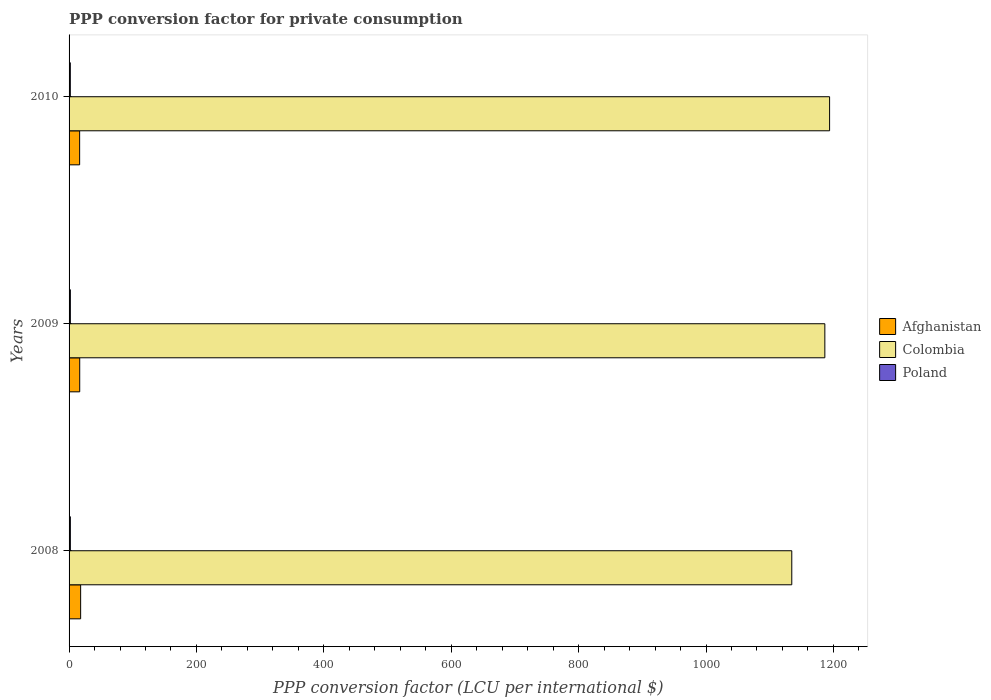How many different coloured bars are there?
Offer a very short reply. 3. Are the number of bars on each tick of the Y-axis equal?
Your response must be concise. Yes. How many bars are there on the 1st tick from the top?
Ensure brevity in your answer.  3. What is the label of the 3rd group of bars from the top?
Your answer should be compact. 2008. What is the PPP conversion factor for private consumption in Afghanistan in 2010?
Offer a terse response. 16.59. Across all years, what is the maximum PPP conversion factor for private consumption in Poland?
Your response must be concise. 2.02. Across all years, what is the minimum PPP conversion factor for private consumption in Poland?
Your answer should be very brief. 1.96. In which year was the PPP conversion factor for private consumption in Colombia maximum?
Provide a short and direct response. 2010. What is the total PPP conversion factor for private consumption in Poland in the graph?
Your response must be concise. 6. What is the difference between the PPP conversion factor for private consumption in Afghanistan in 2009 and that in 2010?
Offer a very short reply. 0.12. What is the difference between the PPP conversion factor for private consumption in Poland in 2010 and the PPP conversion factor for private consumption in Afghanistan in 2008?
Provide a succinct answer. -16.19. What is the average PPP conversion factor for private consumption in Poland per year?
Keep it short and to the point. 2. In the year 2010, what is the difference between the PPP conversion factor for private consumption in Colombia and PPP conversion factor for private consumption in Afghanistan?
Ensure brevity in your answer.  1177.42. In how many years, is the PPP conversion factor for private consumption in Poland greater than 920 LCU?
Offer a terse response. 0. What is the ratio of the PPP conversion factor for private consumption in Poland in 2008 to that in 2009?
Your response must be concise. 1. Is the PPP conversion factor for private consumption in Poland in 2008 less than that in 2009?
Offer a very short reply. No. Is the difference between the PPP conversion factor for private consumption in Colombia in 2009 and 2010 greater than the difference between the PPP conversion factor for private consumption in Afghanistan in 2009 and 2010?
Provide a succinct answer. No. What is the difference between the highest and the second highest PPP conversion factor for private consumption in Colombia?
Your response must be concise. 7.45. What is the difference between the highest and the lowest PPP conversion factor for private consumption in Afghanistan?
Your response must be concise. 1.57. In how many years, is the PPP conversion factor for private consumption in Afghanistan greater than the average PPP conversion factor for private consumption in Afghanistan taken over all years?
Give a very brief answer. 1. Is it the case that in every year, the sum of the PPP conversion factor for private consumption in Poland and PPP conversion factor for private consumption in Colombia is greater than the PPP conversion factor for private consumption in Afghanistan?
Provide a succinct answer. Yes. Are all the bars in the graph horizontal?
Ensure brevity in your answer.  Yes. Are the values on the major ticks of X-axis written in scientific E-notation?
Make the answer very short. No. Does the graph contain any zero values?
Offer a very short reply. No. Does the graph contain grids?
Make the answer very short. No. Where does the legend appear in the graph?
Your answer should be very brief. Center right. What is the title of the graph?
Your answer should be compact. PPP conversion factor for private consumption. What is the label or title of the X-axis?
Offer a very short reply. PPP conversion factor (LCU per international $). What is the PPP conversion factor (LCU per international $) in Afghanistan in 2008?
Provide a short and direct response. 18.15. What is the PPP conversion factor (LCU per international $) of Colombia in 2008?
Make the answer very short. 1134.65. What is the PPP conversion factor (LCU per international $) of Poland in 2008?
Offer a very short reply. 2.02. What is the PPP conversion factor (LCU per international $) of Afghanistan in 2009?
Keep it short and to the point. 16.71. What is the PPP conversion factor (LCU per international $) in Colombia in 2009?
Make the answer very short. 1186.56. What is the PPP conversion factor (LCU per international $) in Poland in 2009?
Ensure brevity in your answer.  2.02. What is the PPP conversion factor (LCU per international $) in Afghanistan in 2010?
Your answer should be very brief. 16.59. What is the PPP conversion factor (LCU per international $) of Colombia in 2010?
Offer a very short reply. 1194.01. What is the PPP conversion factor (LCU per international $) in Poland in 2010?
Your response must be concise. 1.96. Across all years, what is the maximum PPP conversion factor (LCU per international $) in Afghanistan?
Your answer should be compact. 18.15. Across all years, what is the maximum PPP conversion factor (LCU per international $) of Colombia?
Make the answer very short. 1194.01. Across all years, what is the maximum PPP conversion factor (LCU per international $) of Poland?
Your response must be concise. 2.02. Across all years, what is the minimum PPP conversion factor (LCU per international $) of Afghanistan?
Provide a succinct answer. 16.59. Across all years, what is the minimum PPP conversion factor (LCU per international $) in Colombia?
Offer a very short reply. 1134.65. Across all years, what is the minimum PPP conversion factor (LCU per international $) in Poland?
Give a very brief answer. 1.96. What is the total PPP conversion factor (LCU per international $) in Afghanistan in the graph?
Offer a very short reply. 51.45. What is the total PPP conversion factor (LCU per international $) in Colombia in the graph?
Offer a very short reply. 3515.21. What is the total PPP conversion factor (LCU per international $) in Poland in the graph?
Make the answer very short. 6. What is the difference between the PPP conversion factor (LCU per international $) in Afghanistan in 2008 and that in 2009?
Your answer should be very brief. 1.44. What is the difference between the PPP conversion factor (LCU per international $) in Colombia in 2008 and that in 2009?
Give a very brief answer. -51.91. What is the difference between the PPP conversion factor (LCU per international $) in Poland in 2008 and that in 2009?
Give a very brief answer. 0. What is the difference between the PPP conversion factor (LCU per international $) in Afghanistan in 2008 and that in 2010?
Ensure brevity in your answer.  1.57. What is the difference between the PPP conversion factor (LCU per international $) of Colombia in 2008 and that in 2010?
Provide a short and direct response. -59.36. What is the difference between the PPP conversion factor (LCU per international $) of Poland in 2008 and that in 2010?
Provide a succinct answer. 0.06. What is the difference between the PPP conversion factor (LCU per international $) of Afghanistan in 2009 and that in 2010?
Provide a short and direct response. 0.12. What is the difference between the PPP conversion factor (LCU per international $) in Colombia in 2009 and that in 2010?
Provide a succinct answer. -7.45. What is the difference between the PPP conversion factor (LCU per international $) in Poland in 2009 and that in 2010?
Your answer should be very brief. 0.06. What is the difference between the PPP conversion factor (LCU per international $) of Afghanistan in 2008 and the PPP conversion factor (LCU per international $) of Colombia in 2009?
Ensure brevity in your answer.  -1168.4. What is the difference between the PPP conversion factor (LCU per international $) of Afghanistan in 2008 and the PPP conversion factor (LCU per international $) of Poland in 2009?
Offer a very short reply. 16.14. What is the difference between the PPP conversion factor (LCU per international $) in Colombia in 2008 and the PPP conversion factor (LCU per international $) in Poland in 2009?
Ensure brevity in your answer.  1132.63. What is the difference between the PPP conversion factor (LCU per international $) of Afghanistan in 2008 and the PPP conversion factor (LCU per international $) of Colombia in 2010?
Keep it short and to the point. -1175.85. What is the difference between the PPP conversion factor (LCU per international $) of Afghanistan in 2008 and the PPP conversion factor (LCU per international $) of Poland in 2010?
Offer a terse response. 16.19. What is the difference between the PPP conversion factor (LCU per international $) in Colombia in 2008 and the PPP conversion factor (LCU per international $) in Poland in 2010?
Your response must be concise. 1132.69. What is the difference between the PPP conversion factor (LCU per international $) in Afghanistan in 2009 and the PPP conversion factor (LCU per international $) in Colombia in 2010?
Offer a very short reply. -1177.3. What is the difference between the PPP conversion factor (LCU per international $) in Afghanistan in 2009 and the PPP conversion factor (LCU per international $) in Poland in 2010?
Your response must be concise. 14.75. What is the difference between the PPP conversion factor (LCU per international $) in Colombia in 2009 and the PPP conversion factor (LCU per international $) in Poland in 2010?
Offer a terse response. 1184.6. What is the average PPP conversion factor (LCU per international $) in Afghanistan per year?
Your response must be concise. 17.15. What is the average PPP conversion factor (LCU per international $) in Colombia per year?
Make the answer very short. 1171.74. What is the average PPP conversion factor (LCU per international $) in Poland per year?
Offer a very short reply. 2. In the year 2008, what is the difference between the PPP conversion factor (LCU per international $) of Afghanistan and PPP conversion factor (LCU per international $) of Colombia?
Ensure brevity in your answer.  -1116.5. In the year 2008, what is the difference between the PPP conversion factor (LCU per international $) in Afghanistan and PPP conversion factor (LCU per international $) in Poland?
Give a very brief answer. 16.13. In the year 2008, what is the difference between the PPP conversion factor (LCU per international $) in Colombia and PPP conversion factor (LCU per international $) in Poland?
Your answer should be very brief. 1132.63. In the year 2009, what is the difference between the PPP conversion factor (LCU per international $) in Afghanistan and PPP conversion factor (LCU per international $) in Colombia?
Your response must be concise. -1169.85. In the year 2009, what is the difference between the PPP conversion factor (LCU per international $) of Afghanistan and PPP conversion factor (LCU per international $) of Poland?
Your response must be concise. 14.69. In the year 2009, what is the difference between the PPP conversion factor (LCU per international $) of Colombia and PPP conversion factor (LCU per international $) of Poland?
Give a very brief answer. 1184.54. In the year 2010, what is the difference between the PPP conversion factor (LCU per international $) in Afghanistan and PPP conversion factor (LCU per international $) in Colombia?
Your answer should be compact. -1177.42. In the year 2010, what is the difference between the PPP conversion factor (LCU per international $) of Afghanistan and PPP conversion factor (LCU per international $) of Poland?
Give a very brief answer. 14.63. In the year 2010, what is the difference between the PPP conversion factor (LCU per international $) of Colombia and PPP conversion factor (LCU per international $) of Poland?
Ensure brevity in your answer.  1192.05. What is the ratio of the PPP conversion factor (LCU per international $) of Afghanistan in 2008 to that in 2009?
Offer a very short reply. 1.09. What is the ratio of the PPP conversion factor (LCU per international $) of Colombia in 2008 to that in 2009?
Ensure brevity in your answer.  0.96. What is the ratio of the PPP conversion factor (LCU per international $) of Afghanistan in 2008 to that in 2010?
Give a very brief answer. 1.09. What is the ratio of the PPP conversion factor (LCU per international $) in Colombia in 2008 to that in 2010?
Ensure brevity in your answer.  0.95. What is the ratio of the PPP conversion factor (LCU per international $) of Poland in 2008 to that in 2010?
Your answer should be very brief. 1.03. What is the ratio of the PPP conversion factor (LCU per international $) of Afghanistan in 2009 to that in 2010?
Ensure brevity in your answer.  1.01. What is the ratio of the PPP conversion factor (LCU per international $) in Colombia in 2009 to that in 2010?
Make the answer very short. 0.99. What is the ratio of the PPP conversion factor (LCU per international $) of Poland in 2009 to that in 2010?
Provide a succinct answer. 1.03. What is the difference between the highest and the second highest PPP conversion factor (LCU per international $) in Afghanistan?
Ensure brevity in your answer.  1.44. What is the difference between the highest and the second highest PPP conversion factor (LCU per international $) of Colombia?
Keep it short and to the point. 7.45. What is the difference between the highest and the second highest PPP conversion factor (LCU per international $) of Poland?
Keep it short and to the point. 0. What is the difference between the highest and the lowest PPP conversion factor (LCU per international $) in Afghanistan?
Your response must be concise. 1.57. What is the difference between the highest and the lowest PPP conversion factor (LCU per international $) of Colombia?
Make the answer very short. 59.36. What is the difference between the highest and the lowest PPP conversion factor (LCU per international $) in Poland?
Keep it short and to the point. 0.06. 